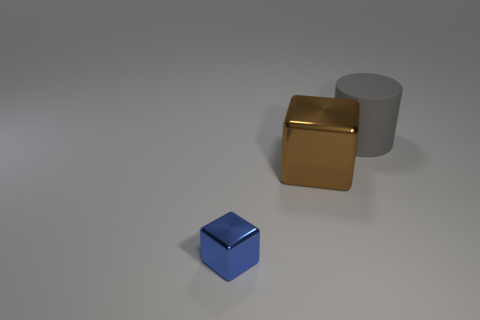Is there anything else that is the same material as the gray thing?
Make the answer very short. No. Is the big cube made of the same material as the blue cube?
Your answer should be very brief. Yes. How many green objects are small blocks or large shiny blocks?
Offer a very short reply. 0. What number of other large gray things have the same shape as the big gray rubber thing?
Your answer should be very brief. 0. What is the material of the big gray object?
Give a very brief answer. Rubber. Are there the same number of big rubber objects in front of the matte thing and cyan balls?
Offer a terse response. Yes. What shape is the metallic thing that is the same size as the cylinder?
Offer a terse response. Cube. Is there a large object that is right of the large thing to the left of the cylinder?
Your response must be concise. Yes. How many large objects are purple metal things or cubes?
Ensure brevity in your answer.  1. Is there a object of the same size as the cylinder?
Your answer should be very brief. Yes. 